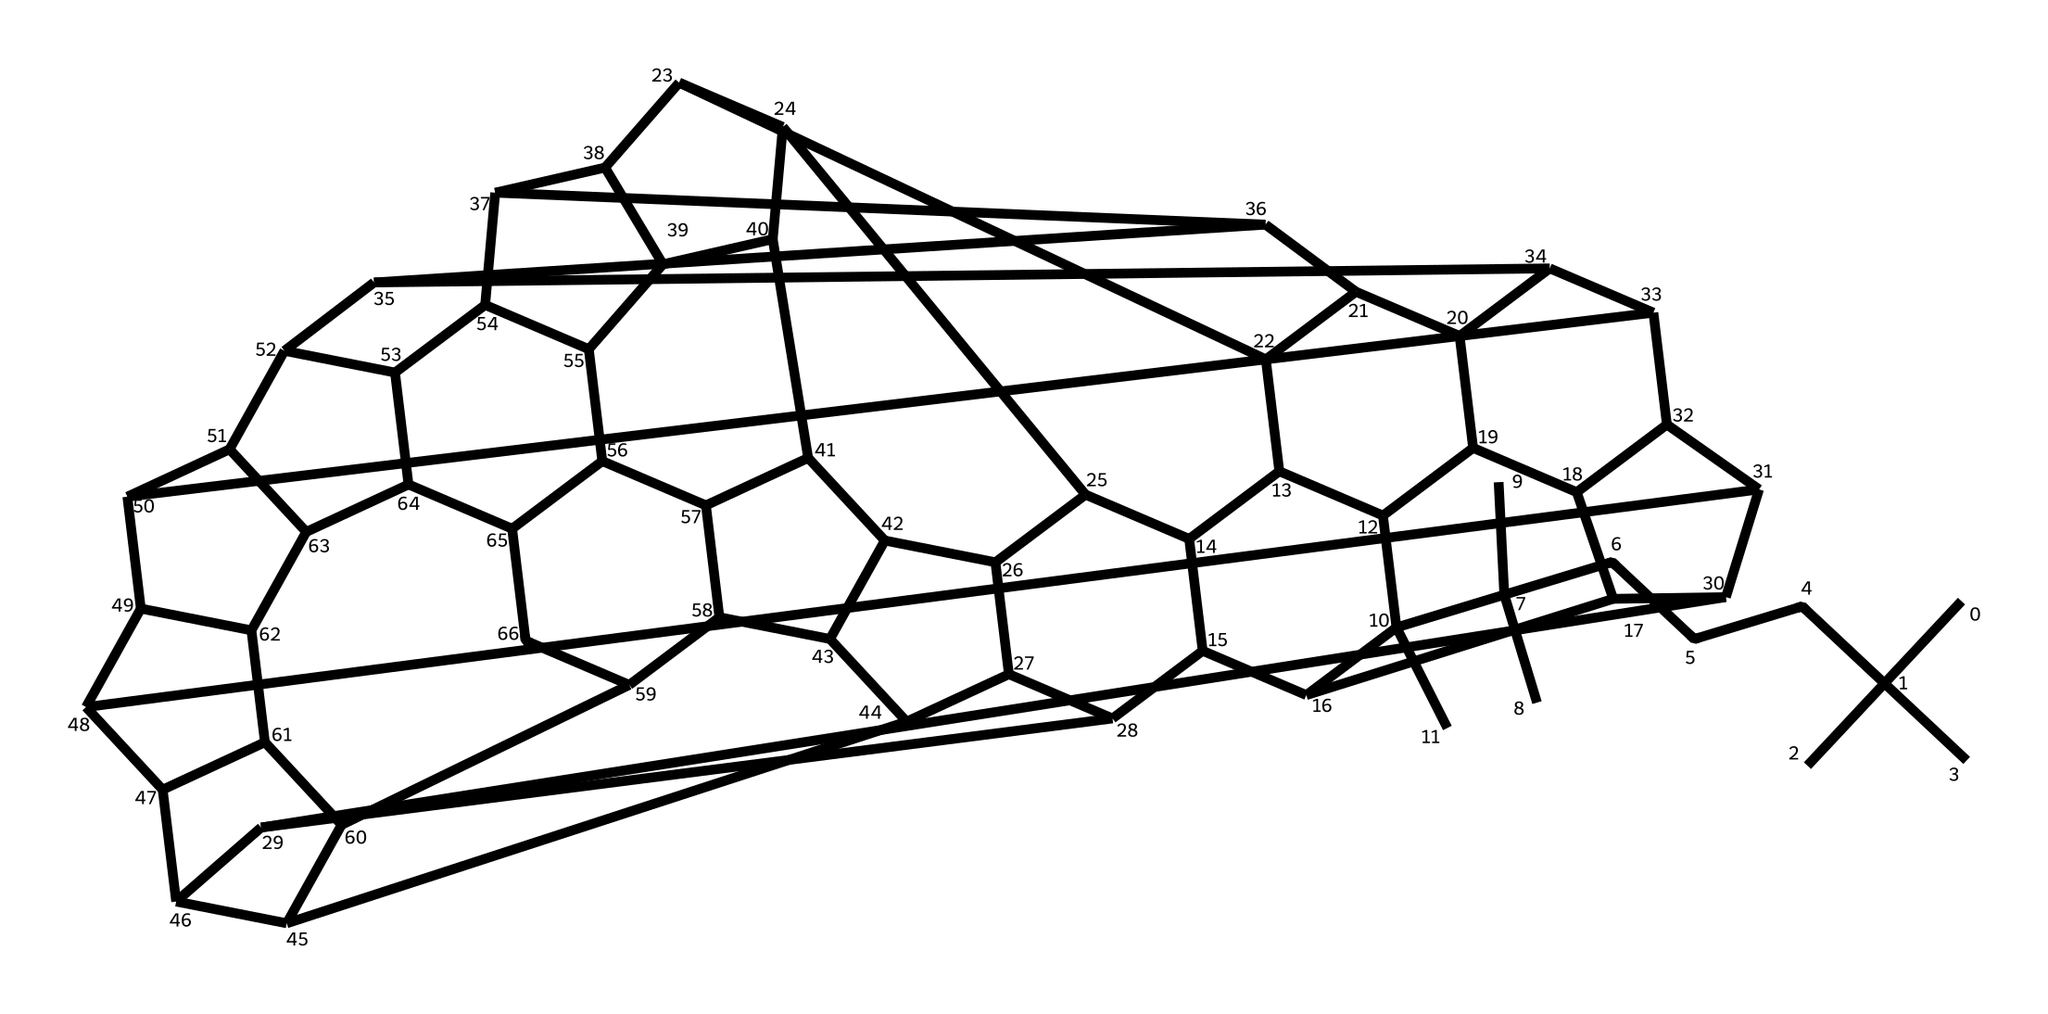What is the primary component of the chemical? The chemical exhibits a large carbon framework typical of fullerenes, specifically consisting of carbon atoms arranged in a spherical or tubular form.
Answer: carbon How many carbon atoms are present in this structure? By analyzing the SMILES representation, we can count the carbon atoms directly, leading to the conclusion that there are 60 carbon atoms forming the fullerene.
Answer: 60 What type of molecular structure does this indicate? The arrangement of the carbon atoms is characteristic of a fullerene, specifically a spherical shape, which is a unique structure due to its hybridized nature of carbon bonds.
Answer: fullerene Does this chemical contain any heteroatoms? The SMILES representation does not indicate the presence of any heteroatoms, as only carbon atoms are shown.
Answer: no What implications does fullerene infusion have for food packaging? Fullerenes enhance the mechanical strength and barrier properties of the packaging material while providing potential antioxidant effects, improving food preservation.
Answer: improved preservation What state of matter is this chemical likely to be found in? Fullerenes can be found in various states, but typically, they exist as solids, particularly at room temperature, due to their stable structure.
Answer: solid 